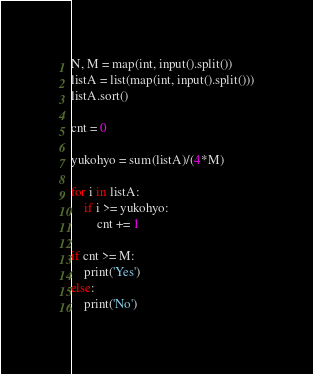<code> <loc_0><loc_0><loc_500><loc_500><_Python_>N, M = map(int, input().split())
listA = list(map(int, input().split()))
listA.sort()

cnt = 0

yukohyo = sum(listA)/(4*M)

for i in listA:
    if i >= yukohyo:
        cnt += 1

if cnt >= M:
    print('Yes')
else:
    print('No')</code> 